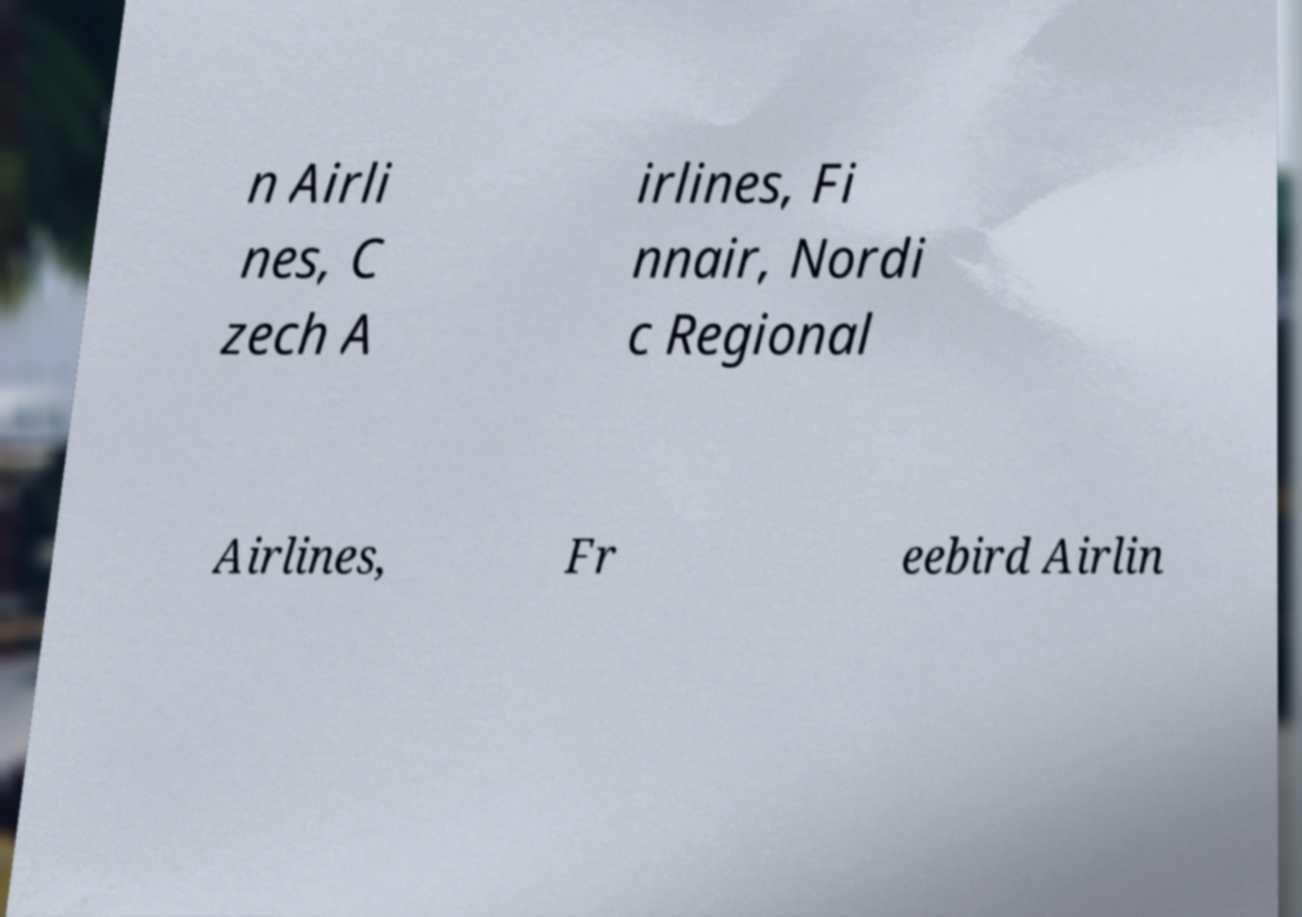Can you read and provide the text displayed in the image?This photo seems to have some interesting text. Can you extract and type it out for me? n Airli nes, C zech A irlines, Fi nnair, Nordi c Regional Airlines, Fr eebird Airlin 